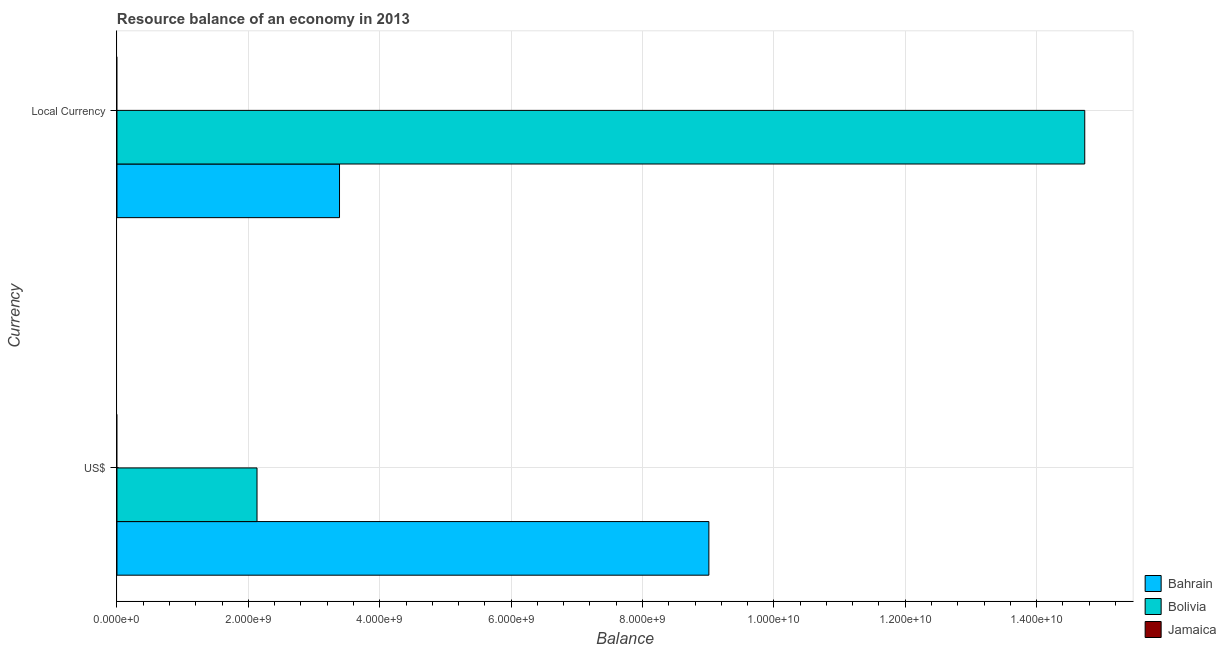How many different coloured bars are there?
Keep it short and to the point. 2. Are the number of bars on each tick of the Y-axis equal?
Offer a very short reply. Yes. How many bars are there on the 2nd tick from the bottom?
Offer a very short reply. 2. What is the label of the 2nd group of bars from the top?
Make the answer very short. US$. What is the resource balance in us$ in Bahrain?
Make the answer very short. 9.01e+09. Across all countries, what is the maximum resource balance in constant us$?
Offer a very short reply. 1.47e+1. In which country was the resource balance in us$ maximum?
Ensure brevity in your answer.  Bahrain. What is the total resource balance in us$ in the graph?
Make the answer very short. 1.11e+1. What is the difference between the resource balance in us$ in Bolivia and that in Bahrain?
Make the answer very short. -6.88e+09. What is the difference between the resource balance in us$ in Jamaica and the resource balance in constant us$ in Bolivia?
Give a very brief answer. -1.47e+1. What is the average resource balance in us$ per country?
Your answer should be compact. 3.71e+09. What is the difference between the resource balance in us$ and resource balance in constant us$ in Bolivia?
Give a very brief answer. -1.26e+1. What is the ratio of the resource balance in us$ in Bahrain to that in Bolivia?
Offer a very short reply. 4.23. Are all the bars in the graph horizontal?
Make the answer very short. Yes. What is the difference between two consecutive major ticks on the X-axis?
Your answer should be very brief. 2.00e+09. Does the graph contain any zero values?
Your answer should be very brief. Yes. How are the legend labels stacked?
Ensure brevity in your answer.  Vertical. What is the title of the graph?
Ensure brevity in your answer.  Resource balance of an economy in 2013. Does "Tuvalu" appear as one of the legend labels in the graph?
Keep it short and to the point. No. What is the label or title of the X-axis?
Your answer should be compact. Balance. What is the label or title of the Y-axis?
Make the answer very short. Currency. What is the Balance of Bahrain in US$?
Ensure brevity in your answer.  9.01e+09. What is the Balance in Bolivia in US$?
Your answer should be compact. 2.13e+09. What is the Balance in Bahrain in Local Currency?
Make the answer very short. 3.39e+09. What is the Balance of Bolivia in Local Currency?
Make the answer very short. 1.47e+1. Across all Currency, what is the maximum Balance of Bahrain?
Provide a succinct answer. 9.01e+09. Across all Currency, what is the maximum Balance of Bolivia?
Offer a terse response. 1.47e+1. Across all Currency, what is the minimum Balance of Bahrain?
Provide a succinct answer. 3.39e+09. Across all Currency, what is the minimum Balance of Bolivia?
Give a very brief answer. 2.13e+09. What is the total Balance in Bahrain in the graph?
Make the answer very short. 1.24e+1. What is the total Balance of Bolivia in the graph?
Your answer should be compact. 1.69e+1. What is the difference between the Balance in Bahrain in US$ and that in Local Currency?
Make the answer very short. 5.62e+09. What is the difference between the Balance in Bolivia in US$ and that in Local Currency?
Offer a very short reply. -1.26e+1. What is the difference between the Balance in Bahrain in US$ and the Balance in Bolivia in Local Currency?
Ensure brevity in your answer.  -5.72e+09. What is the average Balance in Bahrain per Currency?
Provide a succinct answer. 6.20e+09. What is the average Balance of Bolivia per Currency?
Provide a succinct answer. 8.43e+09. What is the average Balance in Jamaica per Currency?
Offer a terse response. 0. What is the difference between the Balance of Bahrain and Balance of Bolivia in US$?
Provide a succinct answer. 6.88e+09. What is the difference between the Balance of Bahrain and Balance of Bolivia in Local Currency?
Your response must be concise. -1.13e+1. What is the ratio of the Balance of Bahrain in US$ to that in Local Currency?
Offer a terse response. 2.66. What is the ratio of the Balance in Bolivia in US$ to that in Local Currency?
Give a very brief answer. 0.14. What is the difference between the highest and the second highest Balance of Bahrain?
Offer a very short reply. 5.62e+09. What is the difference between the highest and the second highest Balance in Bolivia?
Offer a terse response. 1.26e+1. What is the difference between the highest and the lowest Balance of Bahrain?
Give a very brief answer. 5.62e+09. What is the difference between the highest and the lowest Balance of Bolivia?
Offer a terse response. 1.26e+1. 